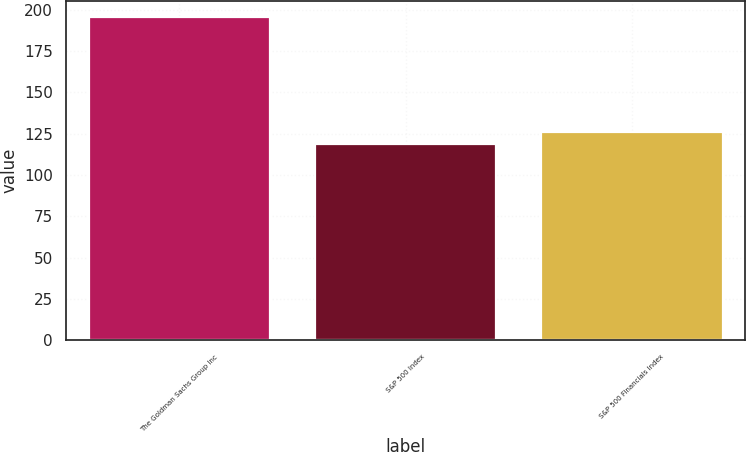Convert chart to OTSL. <chart><loc_0><loc_0><loc_500><loc_500><bar_chart><fcel>The Goldman Sachs Group Inc<fcel>S&P 500 Index<fcel>S&P 500 Financials Index<nl><fcel>195.63<fcel>118.46<fcel>126.18<nl></chart> 